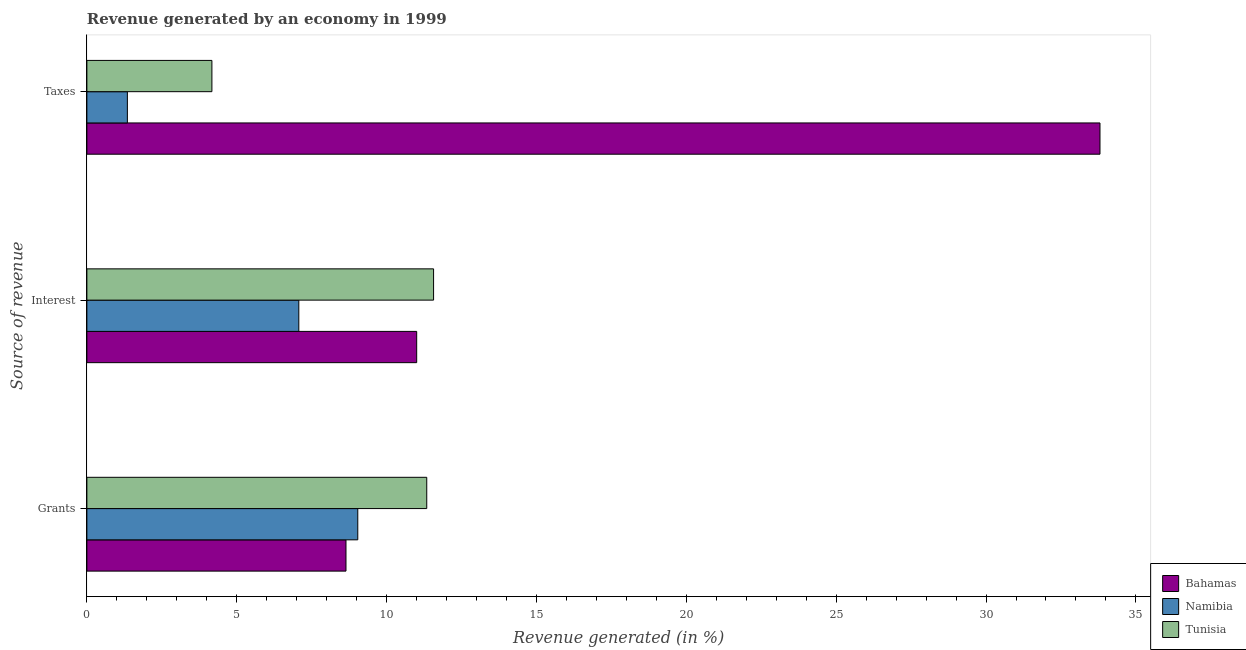How many groups of bars are there?
Give a very brief answer. 3. Are the number of bars per tick equal to the number of legend labels?
Ensure brevity in your answer.  Yes. Are the number of bars on each tick of the Y-axis equal?
Your answer should be very brief. Yes. How many bars are there on the 2nd tick from the top?
Your answer should be compact. 3. How many bars are there on the 3rd tick from the bottom?
Offer a very short reply. 3. What is the label of the 3rd group of bars from the top?
Your answer should be compact. Grants. What is the percentage of revenue generated by taxes in Bahamas?
Make the answer very short. 33.8. Across all countries, what is the maximum percentage of revenue generated by interest?
Your response must be concise. 11.57. Across all countries, what is the minimum percentage of revenue generated by grants?
Your response must be concise. 8.64. In which country was the percentage of revenue generated by taxes maximum?
Your answer should be compact. Bahamas. In which country was the percentage of revenue generated by grants minimum?
Your response must be concise. Bahamas. What is the total percentage of revenue generated by grants in the graph?
Keep it short and to the point. 29.02. What is the difference between the percentage of revenue generated by taxes in Namibia and that in Tunisia?
Make the answer very short. -2.82. What is the difference between the percentage of revenue generated by taxes in Bahamas and the percentage of revenue generated by interest in Namibia?
Your answer should be very brief. 26.73. What is the average percentage of revenue generated by interest per country?
Give a very brief answer. 9.88. What is the difference between the percentage of revenue generated by taxes and percentage of revenue generated by grants in Namibia?
Offer a terse response. -7.69. What is the ratio of the percentage of revenue generated by grants in Tunisia to that in Namibia?
Keep it short and to the point. 1.25. Is the percentage of revenue generated by taxes in Namibia less than that in Bahamas?
Keep it short and to the point. Yes. Is the difference between the percentage of revenue generated by grants in Bahamas and Tunisia greater than the difference between the percentage of revenue generated by interest in Bahamas and Tunisia?
Offer a very short reply. No. What is the difference between the highest and the second highest percentage of revenue generated by interest?
Your answer should be compact. 0.56. What is the difference between the highest and the lowest percentage of revenue generated by taxes?
Make the answer very short. 32.45. What does the 2nd bar from the top in Grants represents?
Ensure brevity in your answer.  Namibia. What does the 1st bar from the bottom in Taxes represents?
Keep it short and to the point. Bahamas. How many bars are there?
Provide a succinct answer. 9. How many countries are there in the graph?
Your answer should be very brief. 3. What is the difference between two consecutive major ticks on the X-axis?
Your response must be concise. 5. Does the graph contain any zero values?
Offer a very short reply. No. How many legend labels are there?
Ensure brevity in your answer.  3. What is the title of the graph?
Your answer should be compact. Revenue generated by an economy in 1999. Does "Finland" appear as one of the legend labels in the graph?
Provide a succinct answer. No. What is the label or title of the X-axis?
Provide a succinct answer. Revenue generated (in %). What is the label or title of the Y-axis?
Offer a very short reply. Source of revenue. What is the Revenue generated (in %) in Bahamas in Grants?
Make the answer very short. 8.64. What is the Revenue generated (in %) of Namibia in Grants?
Provide a succinct answer. 9.04. What is the Revenue generated (in %) of Tunisia in Grants?
Offer a terse response. 11.34. What is the Revenue generated (in %) of Bahamas in Interest?
Your answer should be very brief. 11. What is the Revenue generated (in %) in Namibia in Interest?
Keep it short and to the point. 7.07. What is the Revenue generated (in %) in Tunisia in Interest?
Ensure brevity in your answer.  11.57. What is the Revenue generated (in %) in Bahamas in Taxes?
Your answer should be compact. 33.8. What is the Revenue generated (in %) in Namibia in Taxes?
Offer a terse response. 1.35. What is the Revenue generated (in %) in Tunisia in Taxes?
Offer a very short reply. 4.17. Across all Source of revenue, what is the maximum Revenue generated (in %) of Bahamas?
Make the answer very short. 33.8. Across all Source of revenue, what is the maximum Revenue generated (in %) of Namibia?
Ensure brevity in your answer.  9.04. Across all Source of revenue, what is the maximum Revenue generated (in %) in Tunisia?
Provide a short and direct response. 11.57. Across all Source of revenue, what is the minimum Revenue generated (in %) in Bahamas?
Give a very brief answer. 8.64. Across all Source of revenue, what is the minimum Revenue generated (in %) of Namibia?
Provide a succinct answer. 1.35. Across all Source of revenue, what is the minimum Revenue generated (in %) of Tunisia?
Ensure brevity in your answer.  4.17. What is the total Revenue generated (in %) in Bahamas in the graph?
Provide a succinct answer. 53.45. What is the total Revenue generated (in %) of Namibia in the graph?
Your response must be concise. 17.46. What is the total Revenue generated (in %) in Tunisia in the graph?
Keep it short and to the point. 27.08. What is the difference between the Revenue generated (in %) of Bahamas in Grants and that in Interest?
Your answer should be very brief. -2.36. What is the difference between the Revenue generated (in %) of Namibia in Grants and that in Interest?
Provide a short and direct response. 1.97. What is the difference between the Revenue generated (in %) in Tunisia in Grants and that in Interest?
Keep it short and to the point. -0.23. What is the difference between the Revenue generated (in %) of Bahamas in Grants and that in Taxes?
Your response must be concise. -25.16. What is the difference between the Revenue generated (in %) in Namibia in Grants and that in Taxes?
Your answer should be very brief. 7.69. What is the difference between the Revenue generated (in %) of Tunisia in Grants and that in Taxes?
Your response must be concise. 7.17. What is the difference between the Revenue generated (in %) of Bahamas in Interest and that in Taxes?
Offer a very short reply. -22.8. What is the difference between the Revenue generated (in %) of Namibia in Interest and that in Taxes?
Offer a terse response. 5.72. What is the difference between the Revenue generated (in %) of Tunisia in Interest and that in Taxes?
Offer a very short reply. 7.4. What is the difference between the Revenue generated (in %) of Bahamas in Grants and the Revenue generated (in %) of Namibia in Interest?
Ensure brevity in your answer.  1.57. What is the difference between the Revenue generated (in %) in Bahamas in Grants and the Revenue generated (in %) in Tunisia in Interest?
Provide a succinct answer. -2.92. What is the difference between the Revenue generated (in %) of Namibia in Grants and the Revenue generated (in %) of Tunisia in Interest?
Your answer should be very brief. -2.53. What is the difference between the Revenue generated (in %) of Bahamas in Grants and the Revenue generated (in %) of Namibia in Taxes?
Your answer should be very brief. 7.29. What is the difference between the Revenue generated (in %) of Bahamas in Grants and the Revenue generated (in %) of Tunisia in Taxes?
Offer a terse response. 4.47. What is the difference between the Revenue generated (in %) in Namibia in Grants and the Revenue generated (in %) in Tunisia in Taxes?
Provide a short and direct response. 4.87. What is the difference between the Revenue generated (in %) in Bahamas in Interest and the Revenue generated (in %) in Namibia in Taxes?
Your answer should be compact. 9.65. What is the difference between the Revenue generated (in %) in Bahamas in Interest and the Revenue generated (in %) in Tunisia in Taxes?
Keep it short and to the point. 6.83. What is the difference between the Revenue generated (in %) of Namibia in Interest and the Revenue generated (in %) of Tunisia in Taxes?
Make the answer very short. 2.9. What is the average Revenue generated (in %) of Bahamas per Source of revenue?
Ensure brevity in your answer.  17.82. What is the average Revenue generated (in %) in Namibia per Source of revenue?
Offer a terse response. 5.82. What is the average Revenue generated (in %) in Tunisia per Source of revenue?
Provide a succinct answer. 9.03. What is the difference between the Revenue generated (in %) of Bahamas and Revenue generated (in %) of Namibia in Grants?
Offer a very short reply. -0.39. What is the difference between the Revenue generated (in %) of Bahamas and Revenue generated (in %) of Tunisia in Grants?
Ensure brevity in your answer.  -2.7. What is the difference between the Revenue generated (in %) of Namibia and Revenue generated (in %) of Tunisia in Grants?
Make the answer very short. -2.3. What is the difference between the Revenue generated (in %) of Bahamas and Revenue generated (in %) of Namibia in Interest?
Ensure brevity in your answer.  3.93. What is the difference between the Revenue generated (in %) in Bahamas and Revenue generated (in %) in Tunisia in Interest?
Provide a short and direct response. -0.56. What is the difference between the Revenue generated (in %) in Namibia and Revenue generated (in %) in Tunisia in Interest?
Provide a succinct answer. -4.5. What is the difference between the Revenue generated (in %) in Bahamas and Revenue generated (in %) in Namibia in Taxes?
Your answer should be very brief. 32.45. What is the difference between the Revenue generated (in %) in Bahamas and Revenue generated (in %) in Tunisia in Taxes?
Provide a succinct answer. 29.63. What is the difference between the Revenue generated (in %) in Namibia and Revenue generated (in %) in Tunisia in Taxes?
Make the answer very short. -2.82. What is the ratio of the Revenue generated (in %) in Bahamas in Grants to that in Interest?
Give a very brief answer. 0.79. What is the ratio of the Revenue generated (in %) in Namibia in Grants to that in Interest?
Give a very brief answer. 1.28. What is the ratio of the Revenue generated (in %) of Tunisia in Grants to that in Interest?
Your answer should be compact. 0.98. What is the ratio of the Revenue generated (in %) of Bahamas in Grants to that in Taxes?
Give a very brief answer. 0.26. What is the ratio of the Revenue generated (in %) in Namibia in Grants to that in Taxes?
Your answer should be compact. 6.69. What is the ratio of the Revenue generated (in %) of Tunisia in Grants to that in Taxes?
Give a very brief answer. 2.72. What is the ratio of the Revenue generated (in %) of Bahamas in Interest to that in Taxes?
Provide a short and direct response. 0.33. What is the ratio of the Revenue generated (in %) of Namibia in Interest to that in Taxes?
Your answer should be compact. 5.23. What is the ratio of the Revenue generated (in %) of Tunisia in Interest to that in Taxes?
Ensure brevity in your answer.  2.77. What is the difference between the highest and the second highest Revenue generated (in %) in Bahamas?
Your response must be concise. 22.8. What is the difference between the highest and the second highest Revenue generated (in %) of Namibia?
Make the answer very short. 1.97. What is the difference between the highest and the second highest Revenue generated (in %) of Tunisia?
Your answer should be compact. 0.23. What is the difference between the highest and the lowest Revenue generated (in %) of Bahamas?
Offer a very short reply. 25.16. What is the difference between the highest and the lowest Revenue generated (in %) of Namibia?
Provide a succinct answer. 7.69. What is the difference between the highest and the lowest Revenue generated (in %) in Tunisia?
Provide a succinct answer. 7.4. 